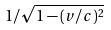<formula> <loc_0><loc_0><loc_500><loc_500>1 / \sqrt { 1 - ( v / c ) ^ { 2 } }</formula> 